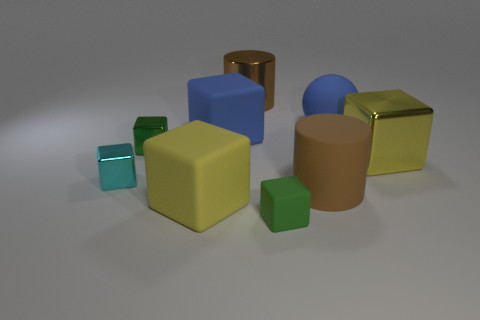Subtract 2 cubes. How many cubes are left? 4 Subtract all cyan blocks. How many blocks are left? 5 Subtract all cyan metal cubes. How many cubes are left? 5 Subtract all blue blocks. Subtract all yellow cylinders. How many blocks are left? 5 Add 1 big cyan spheres. How many objects exist? 10 Subtract all cylinders. How many objects are left? 7 Subtract 0 yellow balls. How many objects are left? 9 Subtract all green rubber cubes. Subtract all large rubber blocks. How many objects are left? 6 Add 2 small green metallic things. How many small green metallic things are left? 3 Add 3 big purple objects. How many big purple objects exist? 3 